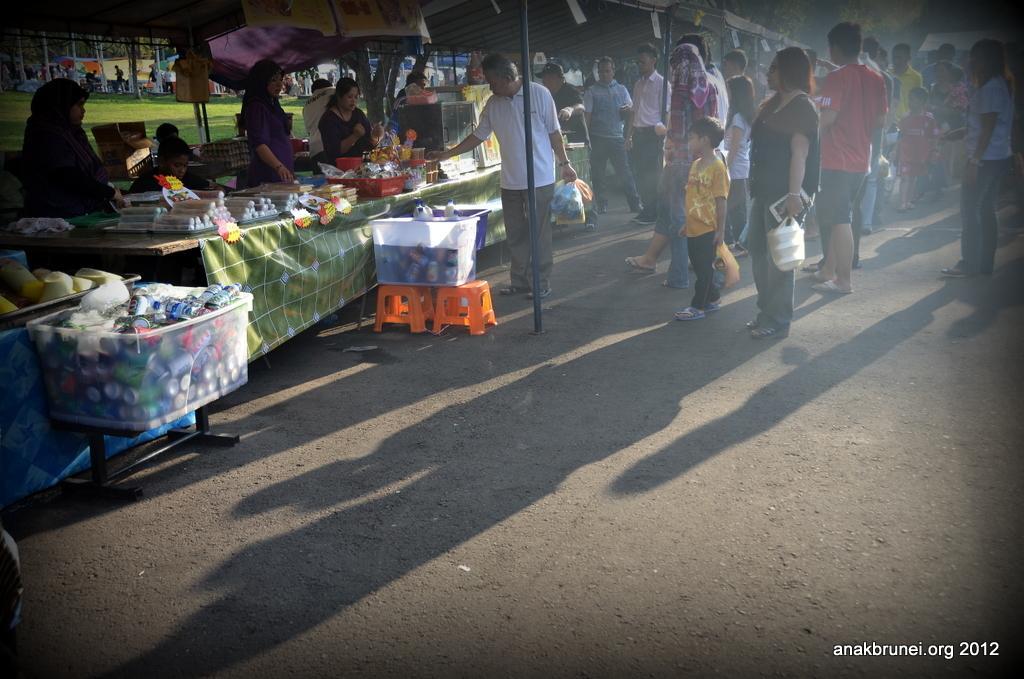Describe this image in one or two sentences. In this image I can see group of people and I can see few stalls and few objects on the table and I can also see few bottles in the basket. 